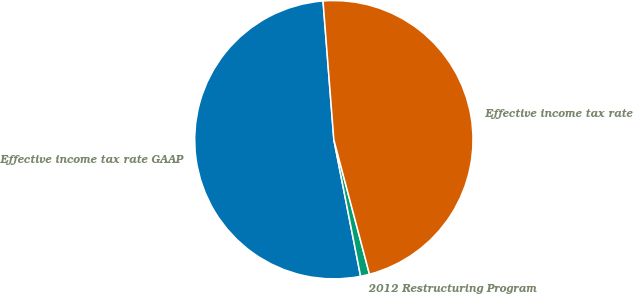Convert chart to OTSL. <chart><loc_0><loc_0><loc_500><loc_500><pie_chart><fcel>Effective income tax rate GAAP<fcel>2012 Restructuring Program<fcel>Effective income tax rate<nl><fcel>51.84%<fcel>1.04%<fcel>47.12%<nl></chart> 